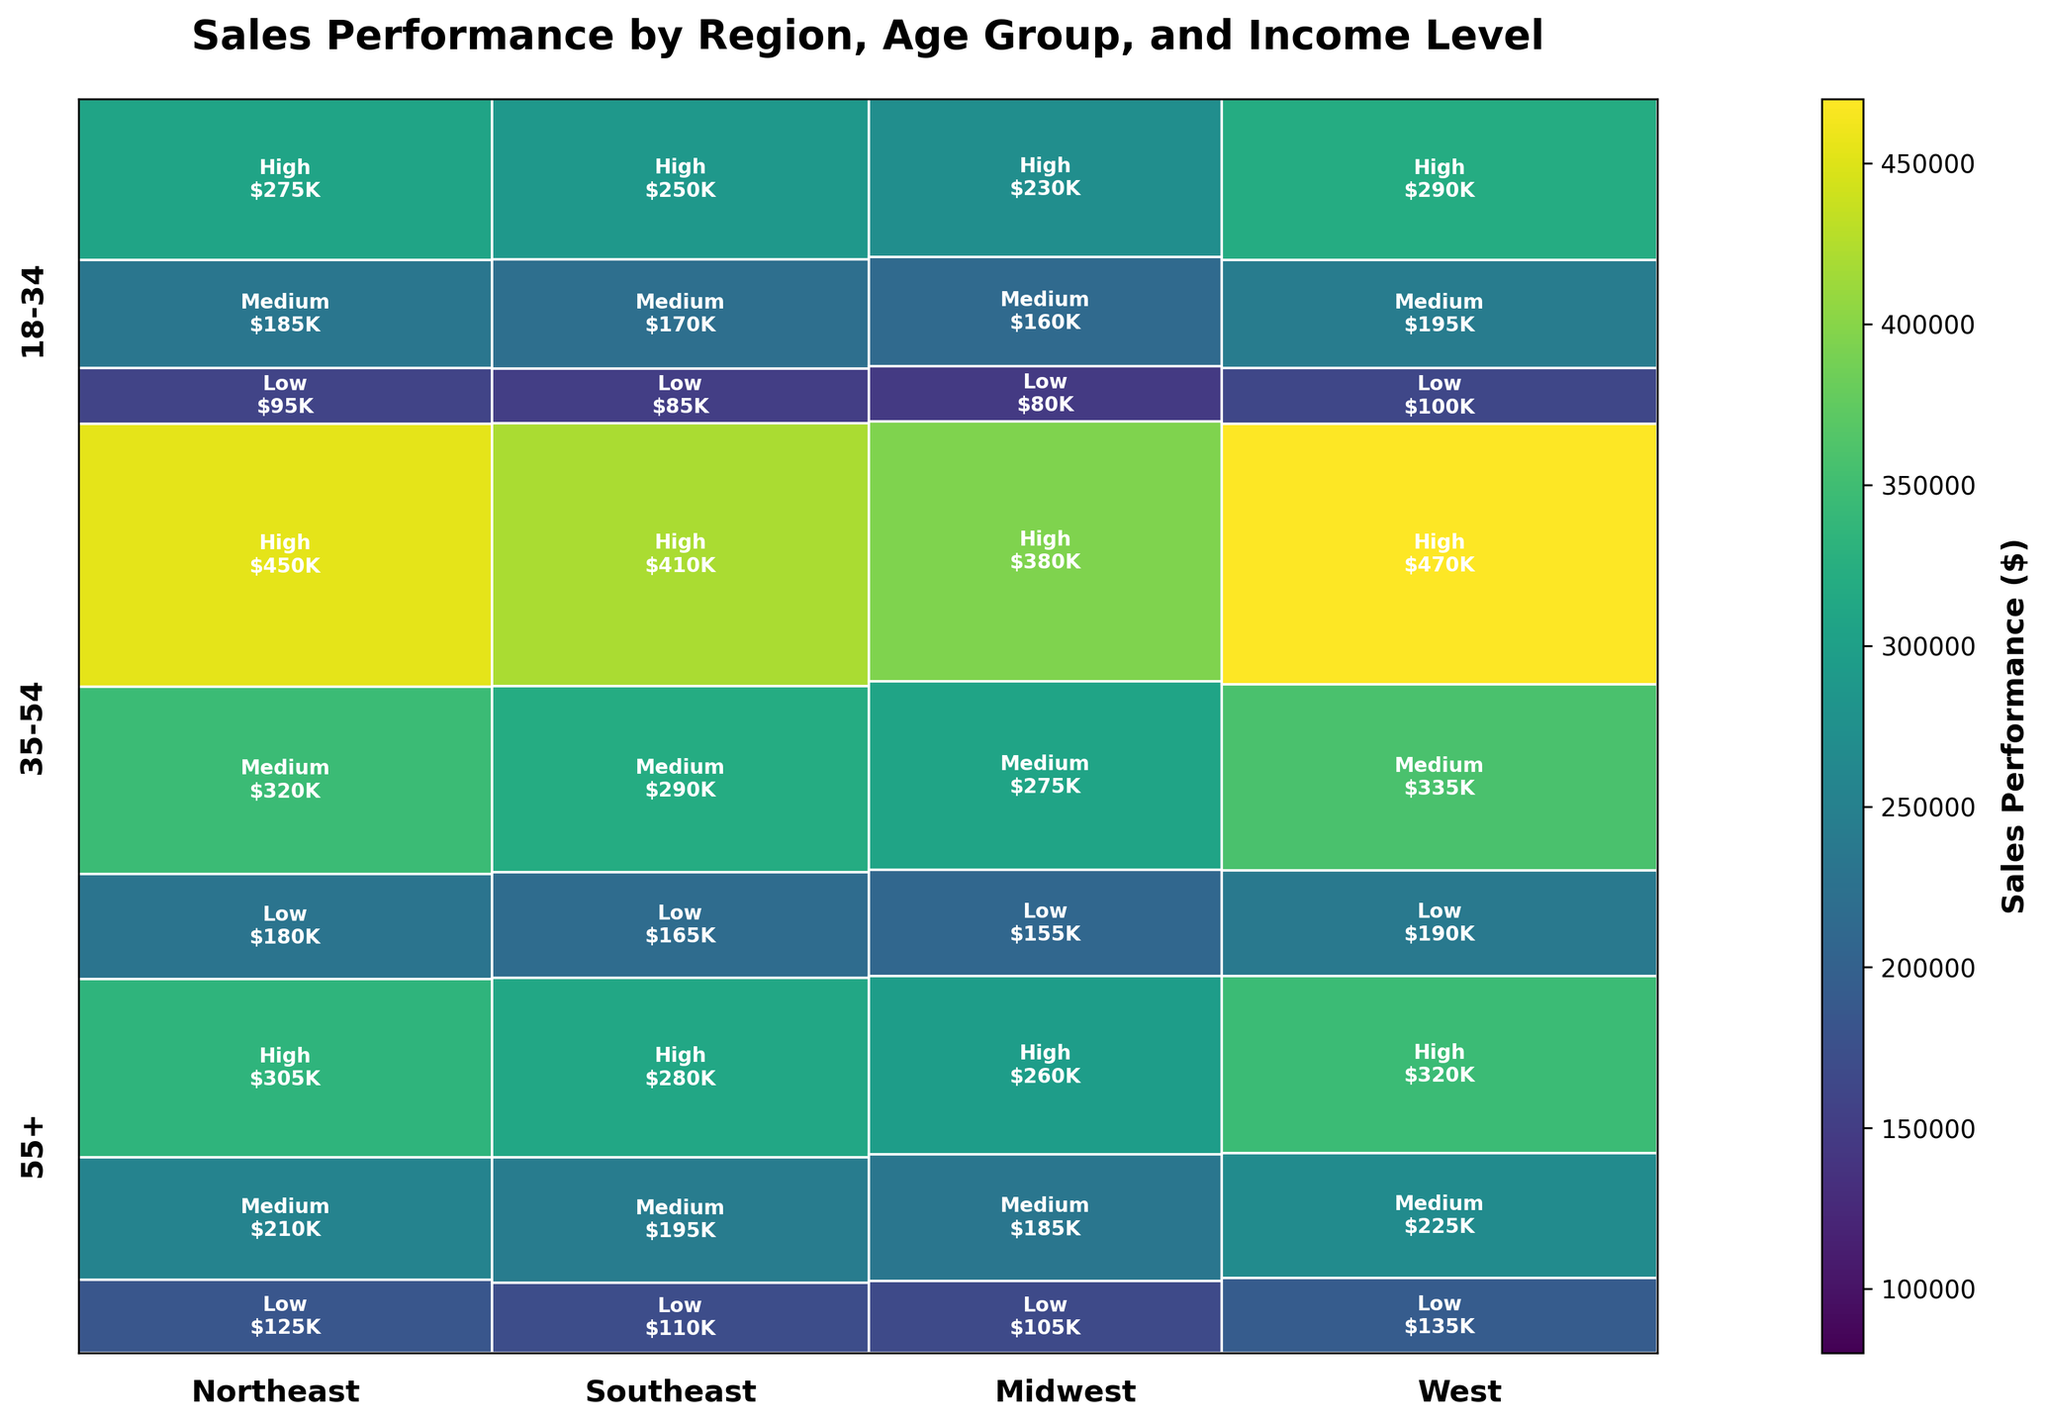What is the total sales performance for the Midwest region? To find the total sales performance for the Midwest region, sum up all the sales performance values for each combination of age group and income level within the Midwest region visible in the plot.
Answer: $1,470,000 Which income level in the Northeast region contributes the most to the sales performance for the 35-54 age group? Look at the part of the mosaic corresponding to the Northeast region and 35-54 age group, and identify which income level rectangle (low, medium, high) has the largest area.
Answer: High How does the sales performance of the 18-34 age group with a medium income level in the West compare to the same group in the Northeast? Find the sales performance value for 18-34 age group with medium income level in both the West and Northeast regions from the plot. Compare the two values directly.
Answer: West has higher performance ($225,000 vs. $210,000) Which region has the smallest contribution from the 55+ age group with a low income level? Identify the smallest area representing the 55+ age group with a low income level across all regions in the mosaic plot.
Answer: Midwest What is the overall sales performance trend based on age groups? Observe the heights of the age group sections across all regions. Determine if there is an apparent trend such as increase or decrease in sales performance with age.
Answer: Highest sales in 35-54, followed by 18-34, then 55+ Between the income levels in the West region for the 35-54 age group, which has the lowest sales performance? In the West region section for the 35-54 age group, identify the smallest rectangle representing either low, medium, or high income levels.
Answer: Low Does the West or Southeast region have a higher sales performance for high-income individuals in any age group? Compare the height of the high-income segments for each age group between the West and Southeast regions.
Answer: West Compare the sales performance of the Midwest region for medium income level across different age groups. Examine the areas of medium-income levels within the Midwest region across all age groups and compare.
Answer: 35-54 > 18-34 > 55+ What is the resolution of details based on income levels for each age group in the Northeast region? Look at the granularity of the data in the mosaic plot for the Northeast region to understand how income levels detail the sales within each age group. Higher sales-related color intensity and difference in rectangle sizes offer more resolution.
Answer: High resolution in 35-54, followed by 18-34, and then 55+ Which income level contributes the least to the overall sales performance across all regions? Summing up and comparing areas across all regions for low, medium, and high income groups. Identify the smallest total area across the mosaic.
Answer: Low 